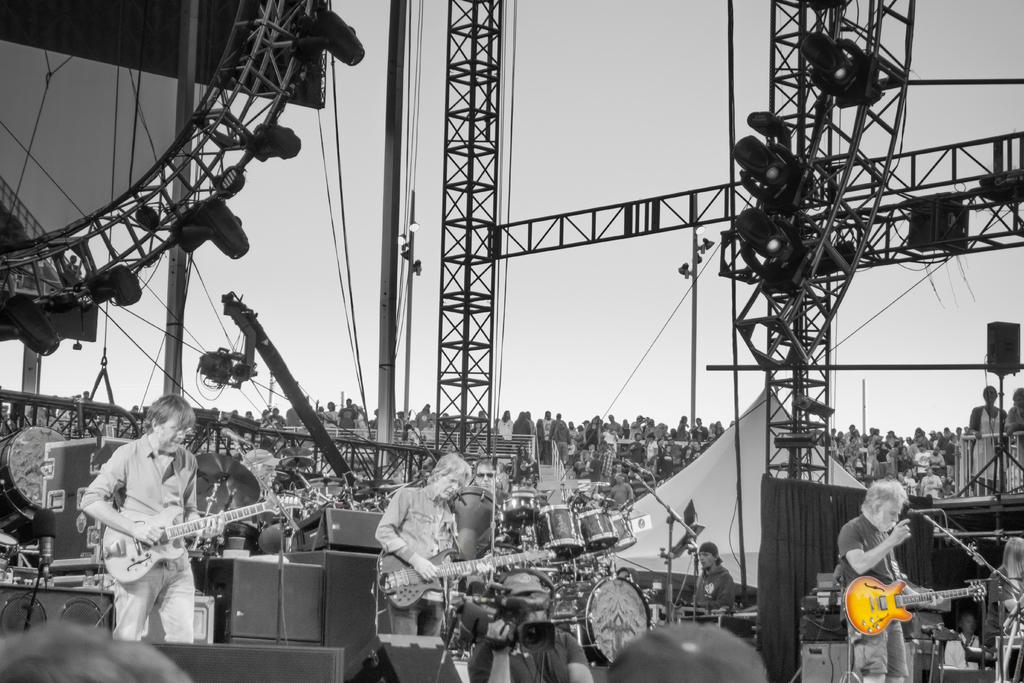What is the color scheme of the image? The image is black and white. What can be seen in the image besides the color scheme? There is an audience visible in the image, as well as a crane with a camera on it, and persons playing musical instruments. Where is the cactus located in the image? There is no cactus present in the image. What type of books can be seen in the library in the image? There is no library present in the image. 